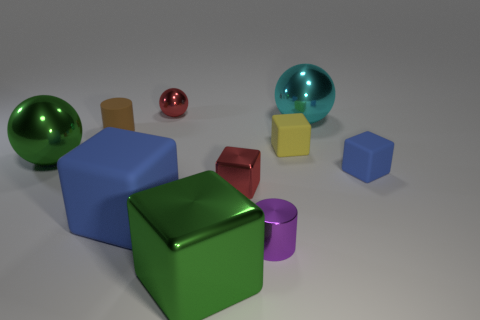Are there any big metal spheres that have the same color as the big shiny block?
Make the answer very short. Yes. What is the size of the green sphere that is made of the same material as the cyan sphere?
Your answer should be compact. Large. There is a red metallic object behind the tiny matte cube that is in front of the big green thing to the left of the tiny brown matte cylinder; what is its shape?
Provide a succinct answer. Sphere. The green shiny object that is the same shape as the large cyan thing is what size?
Your answer should be compact. Large. What size is the object that is on the right side of the big green block and behind the small brown matte object?
Your answer should be very brief. Large. There is a big thing that is the same color as the big metallic cube; what shape is it?
Provide a short and direct response. Sphere. The big matte block has what color?
Give a very brief answer. Blue. There is a green metal thing in front of the green sphere; what size is it?
Your answer should be very brief. Large. What number of tiny brown matte things are on the right side of the small red metallic object that is to the left of the big shiny thing that is in front of the purple metallic cylinder?
Offer a terse response. 0. The object that is right of the large metal object that is behind the large green metallic ball is what color?
Offer a terse response. Blue. 